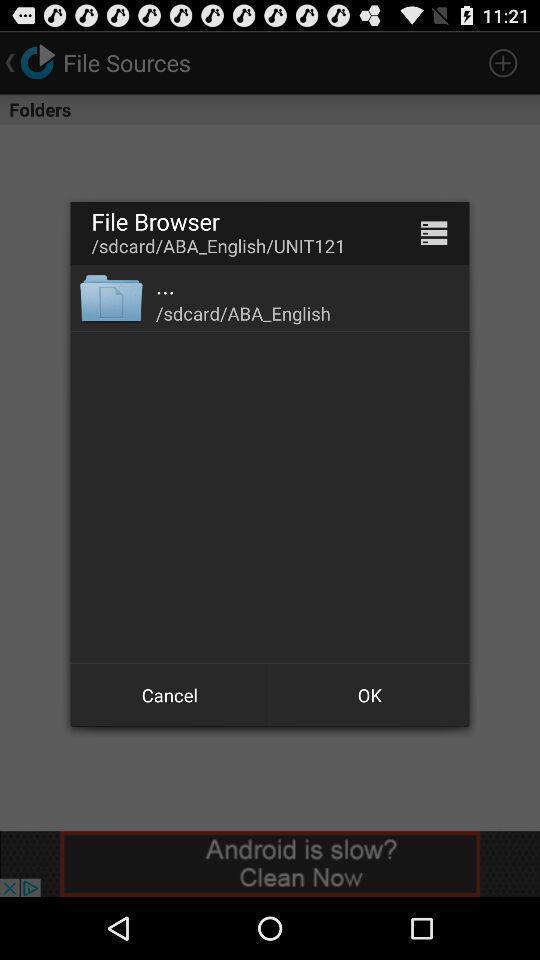Describe the key features of this screenshot. Pop-up window showing a file. 